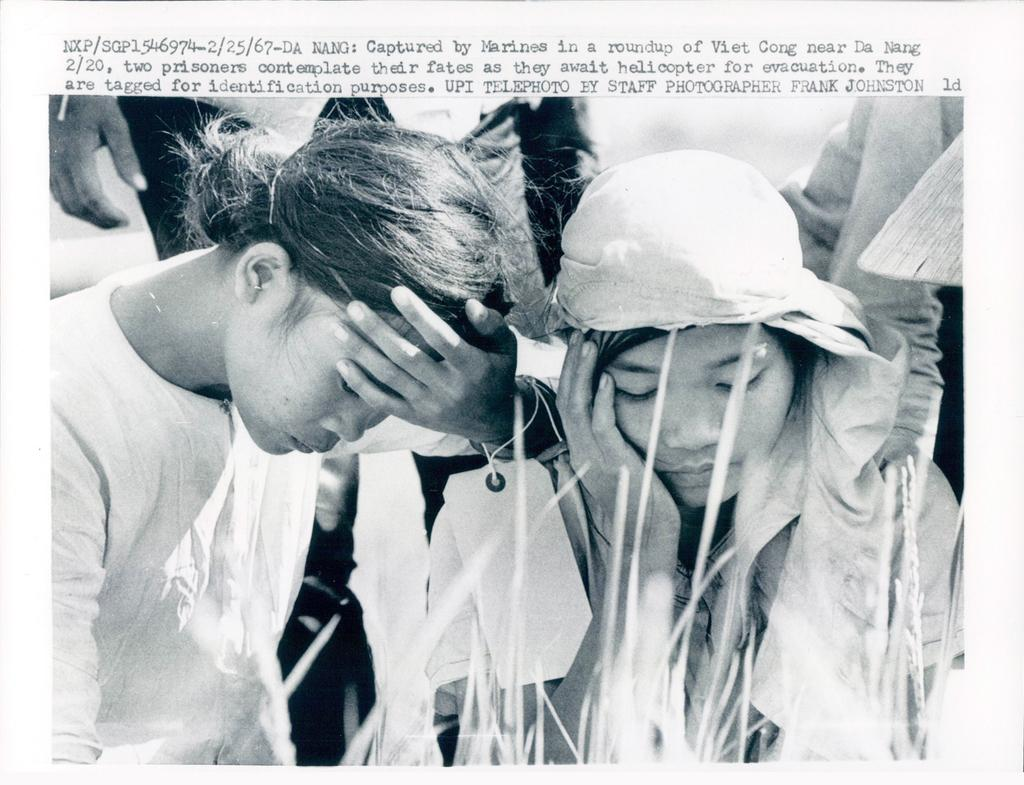What is the color scheme of the picture? The picture is black and white. What can be seen in the picture besides the color scheme? There are people in the picture. Is there any text or writing in the picture? Yes, there is writing on the picture. What type of seed can be seen growing in the picture? There is no seed or plant visible in the picture; it is a black and white image featuring people and writing. Can you tell me the color of the paint used on the giraffe in the picture? There is no giraffe present in the picture; it is a black and white image featuring people and writing. 